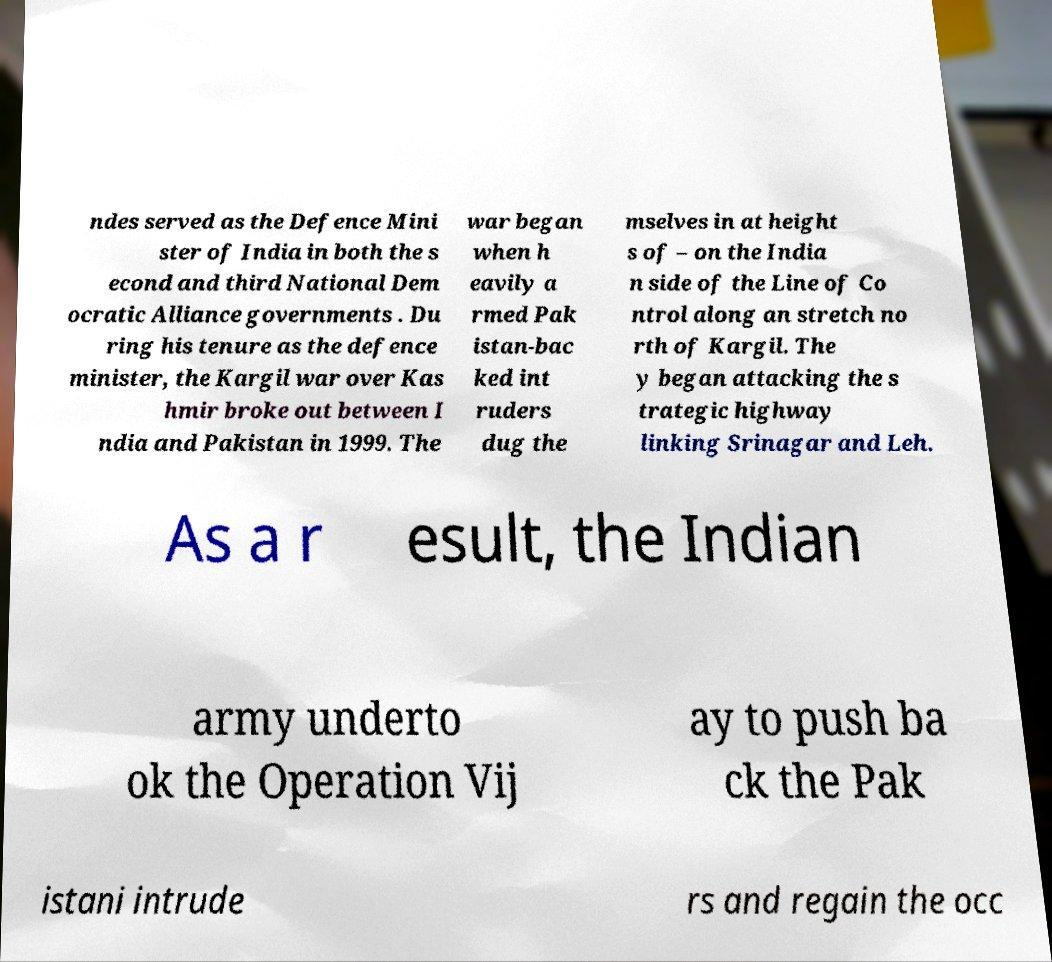Please identify and transcribe the text found in this image. ndes served as the Defence Mini ster of India in both the s econd and third National Dem ocratic Alliance governments . Du ring his tenure as the defence minister, the Kargil war over Kas hmir broke out between I ndia and Pakistan in 1999. The war began when h eavily a rmed Pak istan-bac ked int ruders dug the mselves in at height s of – on the India n side of the Line of Co ntrol along an stretch no rth of Kargil. The y began attacking the s trategic highway linking Srinagar and Leh. As a r esult, the Indian army underto ok the Operation Vij ay to push ba ck the Pak istani intrude rs and regain the occ 